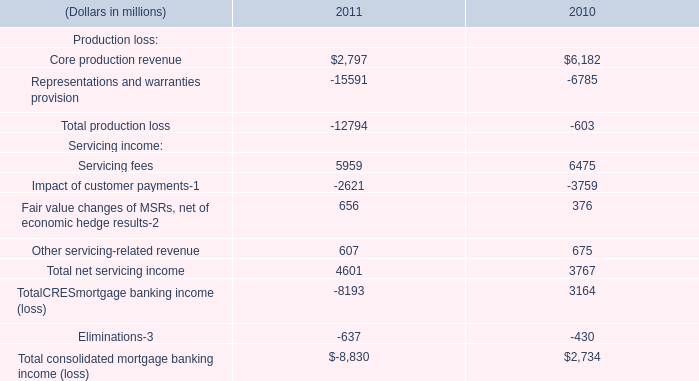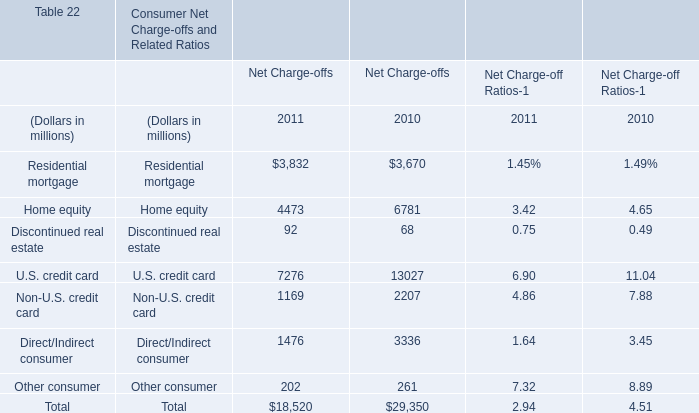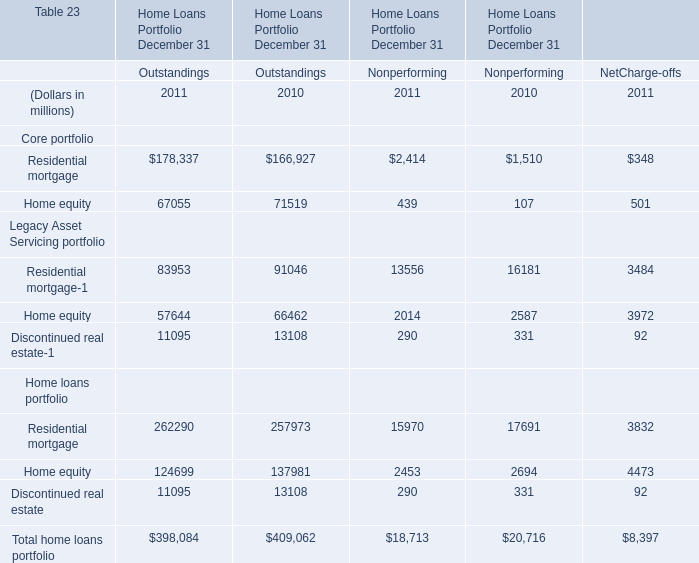How many Outstandings are greater than 262290 in 2011? 
Answer: 0. 